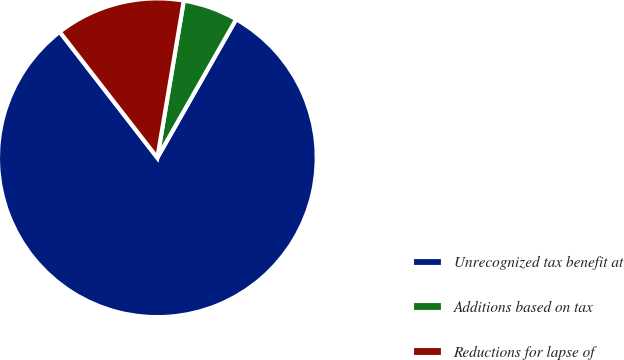Convert chart to OTSL. <chart><loc_0><loc_0><loc_500><loc_500><pie_chart><fcel>Unrecognized tax benefit at<fcel>Additions based on tax<fcel>Reductions for lapse of<nl><fcel>81.27%<fcel>5.58%<fcel>13.15%<nl></chart> 